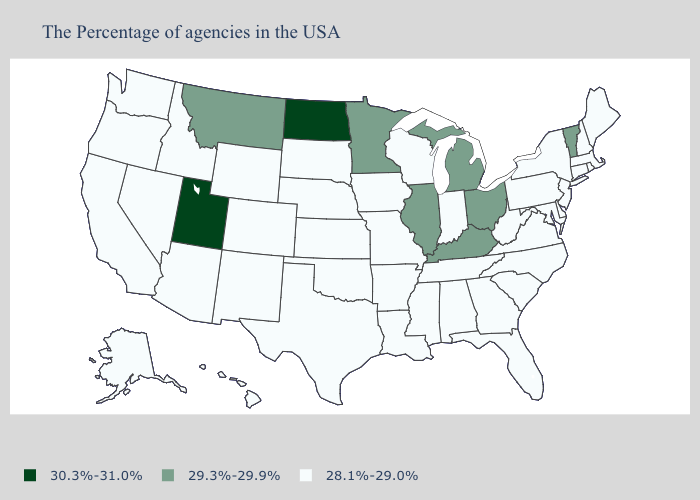What is the value of California?
Keep it brief. 28.1%-29.0%. Name the states that have a value in the range 29.3%-29.9%?
Short answer required. Vermont, Ohio, Michigan, Kentucky, Illinois, Minnesota, Montana. Name the states that have a value in the range 29.3%-29.9%?
Give a very brief answer. Vermont, Ohio, Michigan, Kentucky, Illinois, Minnesota, Montana. Which states have the lowest value in the MidWest?
Be succinct. Indiana, Wisconsin, Missouri, Iowa, Kansas, Nebraska, South Dakota. What is the value of Utah?
Write a very short answer. 30.3%-31.0%. What is the value of Vermont?
Write a very short answer. 29.3%-29.9%. What is the lowest value in the Northeast?
Answer briefly. 28.1%-29.0%. What is the value of Wisconsin?
Write a very short answer. 28.1%-29.0%. Does Wyoming have the highest value in the USA?
Write a very short answer. No. Does South Carolina have the same value as Nebraska?
Quick response, please. Yes. What is the value of Florida?
Write a very short answer. 28.1%-29.0%. Name the states that have a value in the range 28.1%-29.0%?
Write a very short answer. Maine, Massachusetts, Rhode Island, New Hampshire, Connecticut, New York, New Jersey, Delaware, Maryland, Pennsylvania, Virginia, North Carolina, South Carolina, West Virginia, Florida, Georgia, Indiana, Alabama, Tennessee, Wisconsin, Mississippi, Louisiana, Missouri, Arkansas, Iowa, Kansas, Nebraska, Oklahoma, Texas, South Dakota, Wyoming, Colorado, New Mexico, Arizona, Idaho, Nevada, California, Washington, Oregon, Alaska, Hawaii. What is the highest value in states that border Massachusetts?
Keep it brief. 29.3%-29.9%. Does Washington have a lower value than Michigan?
Give a very brief answer. Yes. 